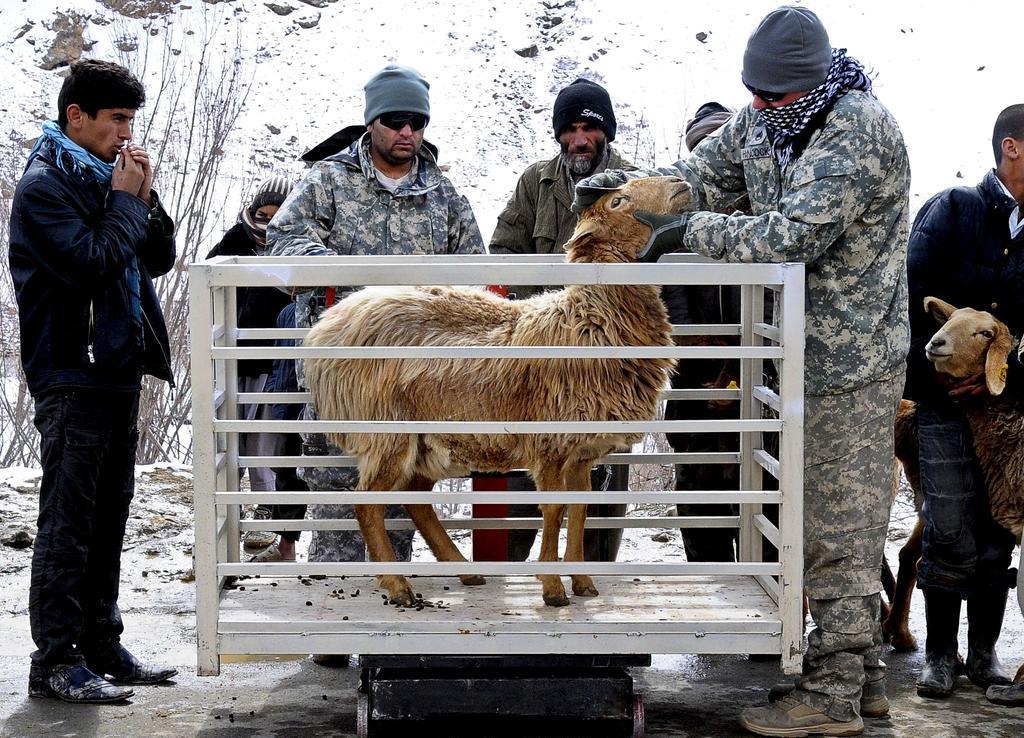How would you summarize this image in a sentence or two? In this image there is a metal cage on which there is a sheep ,around the cage there are few people, on the right side there is a person, sheep, on the left side there is a dry plant. 